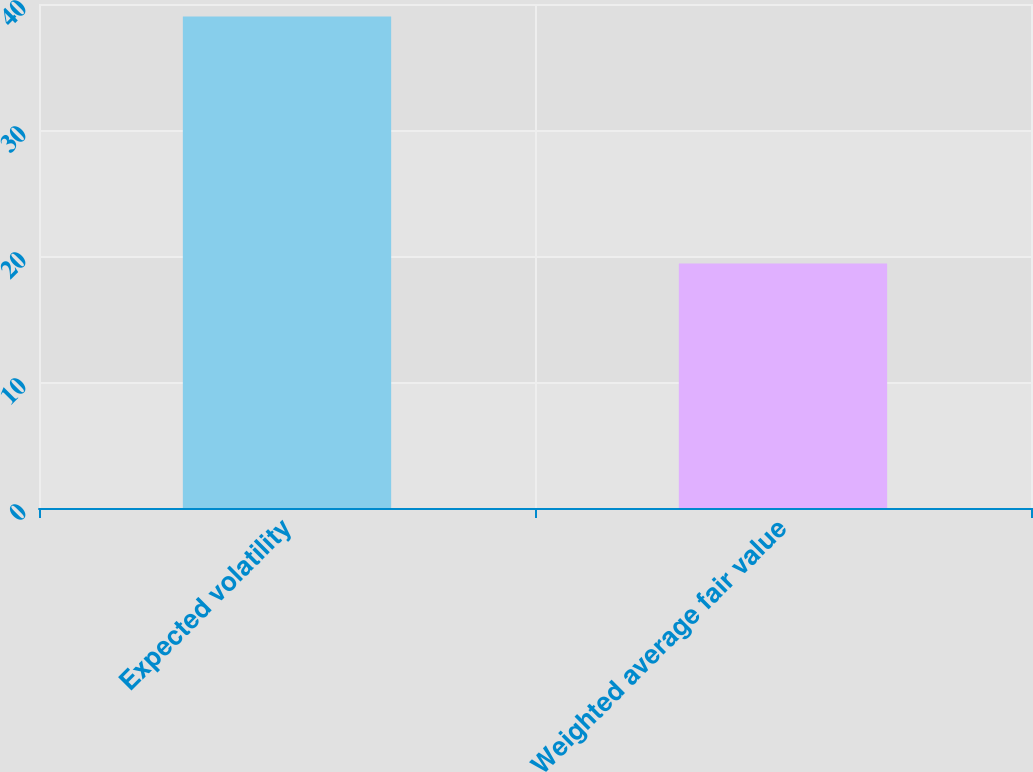<chart> <loc_0><loc_0><loc_500><loc_500><bar_chart><fcel>Expected volatility<fcel>Weighted average fair value<nl><fcel>39<fcel>19.41<nl></chart> 